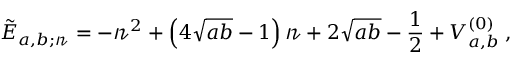<formula> <loc_0><loc_0><loc_500><loc_500>\tilde { E } _ { a , b ; \ m a t h s c r { n } } = - \ m a t h s c r { n } ^ { 2 } + \left ( 4 \sqrt { a b } - 1 \right ) \ m a t h s c r { n } + 2 \sqrt { a b } - \frac { 1 } { 2 } + V _ { a , b } ^ { ( 0 ) } \, ,</formula> 